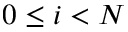Convert formula to latex. <formula><loc_0><loc_0><loc_500><loc_500>0 \leq i < N</formula> 